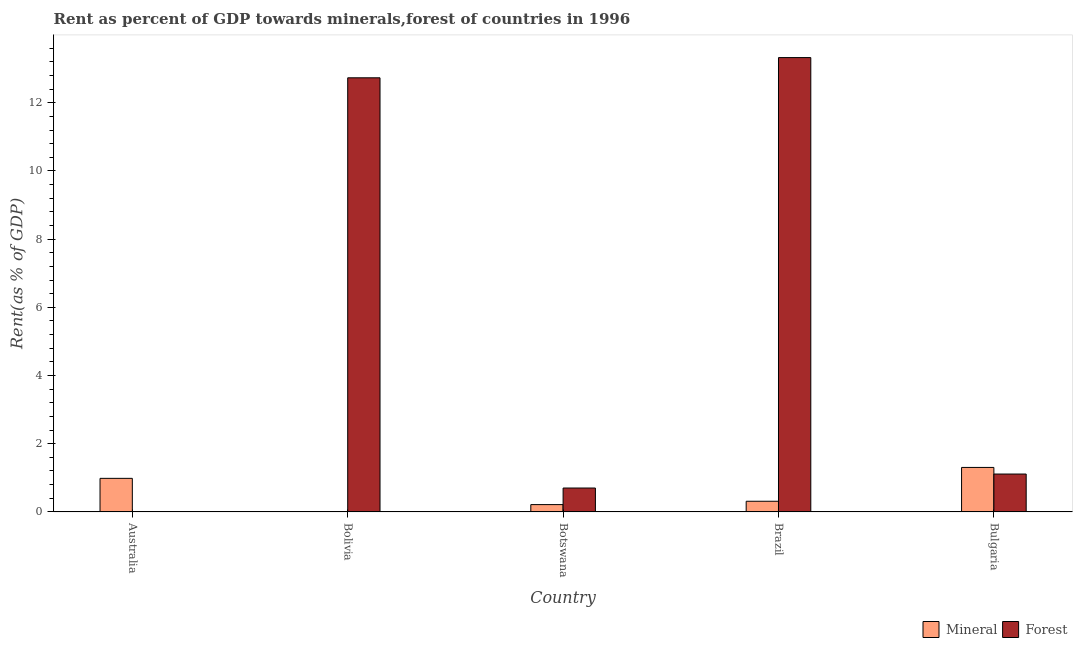How many different coloured bars are there?
Your answer should be compact. 2. Are the number of bars on each tick of the X-axis equal?
Offer a very short reply. Yes. How many bars are there on the 5th tick from the right?
Your answer should be compact. 2. What is the mineral rent in Australia?
Your answer should be very brief. 0.98. Across all countries, what is the maximum mineral rent?
Keep it short and to the point. 1.3. Across all countries, what is the minimum mineral rent?
Make the answer very short. 0.01. In which country was the forest rent maximum?
Provide a short and direct response. Brazil. What is the total forest rent in the graph?
Give a very brief answer. 27.87. What is the difference between the mineral rent in Bolivia and that in Botswana?
Give a very brief answer. -0.21. What is the difference between the mineral rent in Australia and the forest rent in Botswana?
Provide a succinct answer. 0.28. What is the average mineral rent per country?
Offer a very short reply. 0.56. What is the difference between the mineral rent and forest rent in Bulgaria?
Keep it short and to the point. 0.19. In how many countries, is the mineral rent greater than 2.4 %?
Provide a succinct answer. 0. What is the ratio of the forest rent in Australia to that in Bolivia?
Your answer should be very brief. 0. What is the difference between the highest and the second highest forest rent?
Provide a short and direct response. 0.59. What is the difference between the highest and the lowest mineral rent?
Your answer should be very brief. 1.3. In how many countries, is the mineral rent greater than the average mineral rent taken over all countries?
Your response must be concise. 2. What does the 1st bar from the left in Bolivia represents?
Your answer should be compact. Mineral. What does the 1st bar from the right in Bolivia represents?
Your answer should be compact. Forest. How many bars are there?
Provide a short and direct response. 10. Are all the bars in the graph horizontal?
Offer a very short reply. No. What is the difference between two consecutive major ticks on the Y-axis?
Your answer should be very brief. 2. How are the legend labels stacked?
Give a very brief answer. Horizontal. What is the title of the graph?
Provide a succinct answer. Rent as percent of GDP towards minerals,forest of countries in 1996. What is the label or title of the X-axis?
Ensure brevity in your answer.  Country. What is the label or title of the Y-axis?
Make the answer very short. Rent(as % of GDP). What is the Rent(as % of GDP) in Mineral in Australia?
Your response must be concise. 0.98. What is the Rent(as % of GDP) of Forest in Australia?
Make the answer very short. 0. What is the Rent(as % of GDP) of Mineral in Bolivia?
Offer a terse response. 0.01. What is the Rent(as % of GDP) in Forest in Bolivia?
Ensure brevity in your answer.  12.73. What is the Rent(as % of GDP) in Mineral in Botswana?
Provide a succinct answer. 0.21. What is the Rent(as % of GDP) of Forest in Botswana?
Provide a succinct answer. 0.7. What is the Rent(as % of GDP) in Mineral in Brazil?
Give a very brief answer. 0.31. What is the Rent(as % of GDP) of Forest in Brazil?
Your answer should be very brief. 13.33. What is the Rent(as % of GDP) of Mineral in Bulgaria?
Offer a terse response. 1.3. What is the Rent(as % of GDP) of Forest in Bulgaria?
Provide a succinct answer. 1.11. Across all countries, what is the maximum Rent(as % of GDP) in Mineral?
Give a very brief answer. 1.3. Across all countries, what is the maximum Rent(as % of GDP) of Forest?
Give a very brief answer. 13.33. Across all countries, what is the minimum Rent(as % of GDP) in Mineral?
Ensure brevity in your answer.  0.01. Across all countries, what is the minimum Rent(as % of GDP) in Forest?
Your response must be concise. 0. What is the total Rent(as % of GDP) of Mineral in the graph?
Ensure brevity in your answer.  2.82. What is the total Rent(as % of GDP) in Forest in the graph?
Make the answer very short. 27.87. What is the difference between the Rent(as % of GDP) in Mineral in Australia and that in Bolivia?
Your response must be concise. 0.97. What is the difference between the Rent(as % of GDP) of Forest in Australia and that in Bolivia?
Ensure brevity in your answer.  -12.73. What is the difference between the Rent(as % of GDP) in Mineral in Australia and that in Botswana?
Offer a very short reply. 0.77. What is the difference between the Rent(as % of GDP) of Forest in Australia and that in Botswana?
Your answer should be compact. -0.7. What is the difference between the Rent(as % of GDP) of Mineral in Australia and that in Brazil?
Your answer should be compact. 0.67. What is the difference between the Rent(as % of GDP) of Forest in Australia and that in Brazil?
Your answer should be very brief. -13.32. What is the difference between the Rent(as % of GDP) of Mineral in Australia and that in Bulgaria?
Provide a succinct answer. -0.32. What is the difference between the Rent(as % of GDP) in Forest in Australia and that in Bulgaria?
Provide a succinct answer. -1.11. What is the difference between the Rent(as % of GDP) of Mineral in Bolivia and that in Botswana?
Keep it short and to the point. -0.21. What is the difference between the Rent(as % of GDP) of Forest in Bolivia and that in Botswana?
Ensure brevity in your answer.  12.03. What is the difference between the Rent(as % of GDP) in Mineral in Bolivia and that in Brazil?
Provide a short and direct response. -0.3. What is the difference between the Rent(as % of GDP) of Forest in Bolivia and that in Brazil?
Give a very brief answer. -0.59. What is the difference between the Rent(as % of GDP) in Mineral in Bolivia and that in Bulgaria?
Provide a short and direct response. -1.3. What is the difference between the Rent(as % of GDP) of Forest in Bolivia and that in Bulgaria?
Your response must be concise. 11.62. What is the difference between the Rent(as % of GDP) in Mineral in Botswana and that in Brazil?
Keep it short and to the point. -0.1. What is the difference between the Rent(as % of GDP) of Forest in Botswana and that in Brazil?
Your answer should be compact. -12.62. What is the difference between the Rent(as % of GDP) of Mineral in Botswana and that in Bulgaria?
Give a very brief answer. -1.09. What is the difference between the Rent(as % of GDP) of Forest in Botswana and that in Bulgaria?
Offer a very short reply. -0.41. What is the difference between the Rent(as % of GDP) in Mineral in Brazil and that in Bulgaria?
Make the answer very short. -0.99. What is the difference between the Rent(as % of GDP) in Forest in Brazil and that in Bulgaria?
Make the answer very short. 12.21. What is the difference between the Rent(as % of GDP) in Mineral in Australia and the Rent(as % of GDP) in Forest in Bolivia?
Give a very brief answer. -11.75. What is the difference between the Rent(as % of GDP) of Mineral in Australia and the Rent(as % of GDP) of Forest in Botswana?
Keep it short and to the point. 0.28. What is the difference between the Rent(as % of GDP) in Mineral in Australia and the Rent(as % of GDP) in Forest in Brazil?
Provide a succinct answer. -12.34. What is the difference between the Rent(as % of GDP) in Mineral in Australia and the Rent(as % of GDP) in Forest in Bulgaria?
Provide a short and direct response. -0.13. What is the difference between the Rent(as % of GDP) of Mineral in Bolivia and the Rent(as % of GDP) of Forest in Botswana?
Your response must be concise. -0.69. What is the difference between the Rent(as % of GDP) of Mineral in Bolivia and the Rent(as % of GDP) of Forest in Brazil?
Offer a terse response. -13.32. What is the difference between the Rent(as % of GDP) of Mineral in Bolivia and the Rent(as % of GDP) of Forest in Bulgaria?
Give a very brief answer. -1.1. What is the difference between the Rent(as % of GDP) in Mineral in Botswana and the Rent(as % of GDP) in Forest in Brazil?
Provide a succinct answer. -13.11. What is the difference between the Rent(as % of GDP) in Mineral in Botswana and the Rent(as % of GDP) in Forest in Bulgaria?
Keep it short and to the point. -0.9. What is the difference between the Rent(as % of GDP) in Mineral in Brazil and the Rent(as % of GDP) in Forest in Bulgaria?
Make the answer very short. -0.8. What is the average Rent(as % of GDP) of Mineral per country?
Your response must be concise. 0.56. What is the average Rent(as % of GDP) in Forest per country?
Provide a succinct answer. 5.57. What is the difference between the Rent(as % of GDP) in Mineral and Rent(as % of GDP) in Forest in Australia?
Ensure brevity in your answer.  0.98. What is the difference between the Rent(as % of GDP) in Mineral and Rent(as % of GDP) in Forest in Bolivia?
Provide a short and direct response. -12.72. What is the difference between the Rent(as % of GDP) of Mineral and Rent(as % of GDP) of Forest in Botswana?
Offer a terse response. -0.49. What is the difference between the Rent(as % of GDP) of Mineral and Rent(as % of GDP) of Forest in Brazil?
Your response must be concise. -13.01. What is the difference between the Rent(as % of GDP) of Mineral and Rent(as % of GDP) of Forest in Bulgaria?
Give a very brief answer. 0.19. What is the ratio of the Rent(as % of GDP) of Mineral in Australia to that in Bolivia?
Give a very brief answer. 106.48. What is the ratio of the Rent(as % of GDP) of Forest in Australia to that in Bolivia?
Offer a very short reply. 0. What is the ratio of the Rent(as % of GDP) of Mineral in Australia to that in Botswana?
Offer a very short reply. 4.59. What is the ratio of the Rent(as % of GDP) in Forest in Australia to that in Botswana?
Ensure brevity in your answer.  0. What is the ratio of the Rent(as % of GDP) of Mineral in Australia to that in Brazil?
Offer a very short reply. 3.15. What is the ratio of the Rent(as % of GDP) in Mineral in Australia to that in Bulgaria?
Offer a very short reply. 0.75. What is the ratio of the Rent(as % of GDP) in Forest in Australia to that in Bulgaria?
Provide a succinct answer. 0. What is the ratio of the Rent(as % of GDP) of Mineral in Bolivia to that in Botswana?
Your answer should be compact. 0.04. What is the ratio of the Rent(as % of GDP) of Forest in Bolivia to that in Botswana?
Ensure brevity in your answer.  18.18. What is the ratio of the Rent(as % of GDP) in Mineral in Bolivia to that in Brazil?
Offer a terse response. 0.03. What is the ratio of the Rent(as % of GDP) of Forest in Bolivia to that in Brazil?
Keep it short and to the point. 0.96. What is the ratio of the Rent(as % of GDP) in Mineral in Bolivia to that in Bulgaria?
Offer a terse response. 0.01. What is the ratio of the Rent(as % of GDP) in Forest in Bolivia to that in Bulgaria?
Your answer should be compact. 11.46. What is the ratio of the Rent(as % of GDP) of Mineral in Botswana to that in Brazil?
Offer a terse response. 0.69. What is the ratio of the Rent(as % of GDP) in Forest in Botswana to that in Brazil?
Offer a terse response. 0.05. What is the ratio of the Rent(as % of GDP) in Mineral in Botswana to that in Bulgaria?
Ensure brevity in your answer.  0.16. What is the ratio of the Rent(as % of GDP) of Forest in Botswana to that in Bulgaria?
Offer a very short reply. 0.63. What is the ratio of the Rent(as % of GDP) in Mineral in Brazil to that in Bulgaria?
Offer a very short reply. 0.24. What is the ratio of the Rent(as % of GDP) of Forest in Brazil to that in Bulgaria?
Keep it short and to the point. 11.99. What is the difference between the highest and the second highest Rent(as % of GDP) of Mineral?
Keep it short and to the point. 0.32. What is the difference between the highest and the second highest Rent(as % of GDP) in Forest?
Your answer should be very brief. 0.59. What is the difference between the highest and the lowest Rent(as % of GDP) in Mineral?
Provide a short and direct response. 1.3. What is the difference between the highest and the lowest Rent(as % of GDP) of Forest?
Keep it short and to the point. 13.32. 